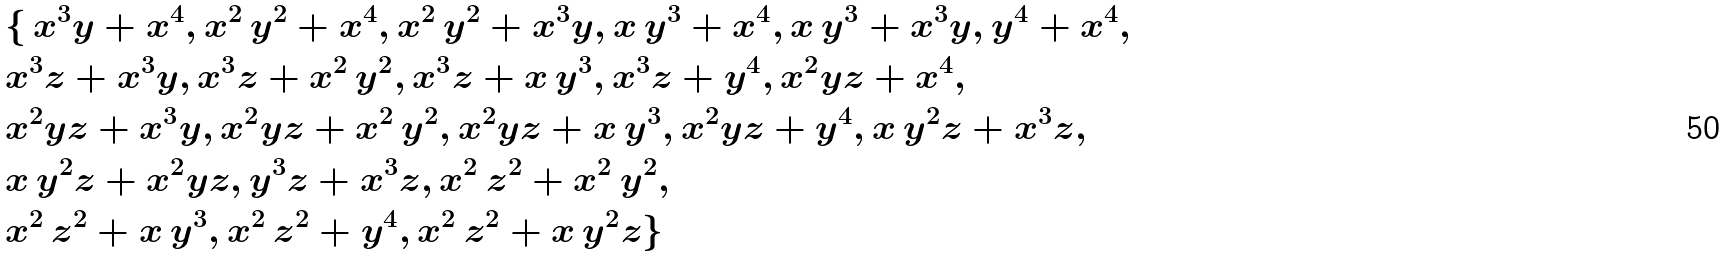<formula> <loc_0><loc_0><loc_500><loc_500>& \{ \, { { x } ^ { 3 } } y + { { x } ^ { 4 } } , { { x } ^ { 2 } } \, { { y } ^ { 2 } } + { { x } ^ { 4 } } , { { x } ^ { 2 } } \, { { y } ^ { 2 } } + { { x } ^ { 3 } } y , x \, { { y } ^ { 3 } } + { { x } ^ { 4 } } , x \, { { y } ^ { 3 } } + { { x } ^ { 3 } } y , { { y } ^ { 4 } } + { { x } ^ { 4 } } , \\ & { { x } ^ { 3 } } z + { { x } ^ { 3 } } y , { { x } ^ { 3 } } z + { { x } ^ { 2 } } \, { { y } ^ { 2 } } , { { x } ^ { 3 } } z + x \, { { y } ^ { 3 } } , { { x } ^ { 3 } } z + { { y } ^ { 4 } } , { { x } ^ { 2 } } y z + { { x } ^ { 4 } } , \\ & { { x } ^ { 2 } } y z + { { x } ^ { 3 } } y , { { x } ^ { 2 } } y z + { { x } ^ { 2 } } \, { { y } ^ { 2 } } , { { x } ^ { 2 } } y z + x \, { { y } ^ { 3 } } , { { x } ^ { 2 } } y z + { { y } ^ { 4 } } , x \, { { y } ^ { 2 } } z + { { x } ^ { 3 } } z , \\ & x \, { { y } ^ { 2 } } z + { { x } ^ { 2 } } y z , { { y } ^ { 3 } } z + { { x } ^ { 3 } } z , { { x } ^ { 2 } } \, { { z } ^ { 2 } } + { { x } ^ { 2 } } \, { { y } ^ { 2 } } , \\ & { { x } ^ { 2 } } \, { { z } ^ { 2 } } + x \, { { y } ^ { 3 } } , { { x } ^ { 2 } } \, { { z } ^ { 2 } } + { { y } ^ { 4 } } , { { x } ^ { 2 } } \, { { z } ^ { 2 } } + x \, { { y } ^ { 2 } } z \}</formula> 